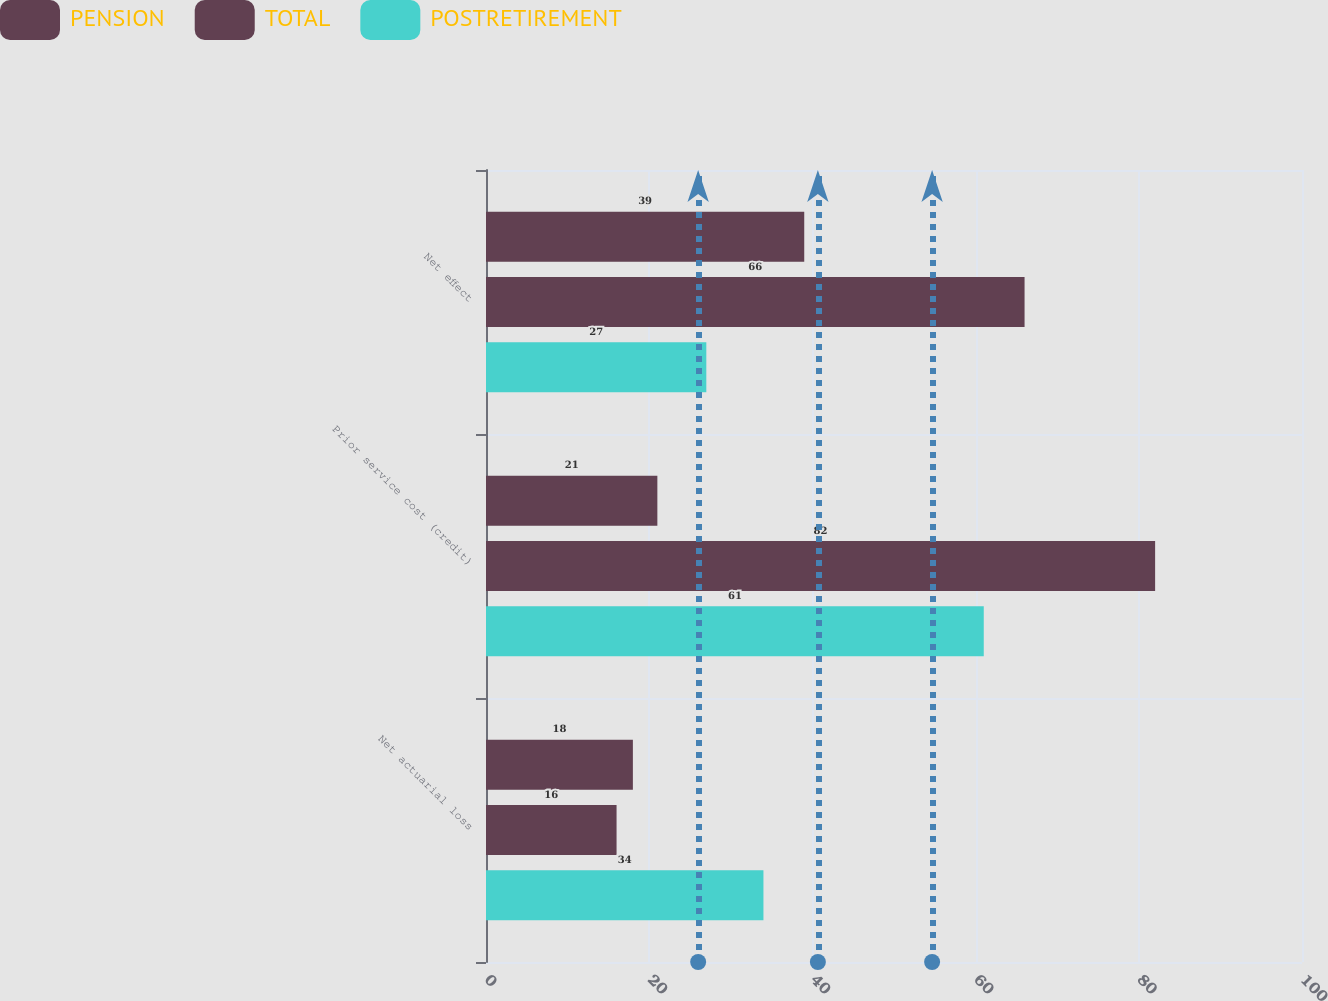<chart> <loc_0><loc_0><loc_500><loc_500><stacked_bar_chart><ecel><fcel>Net actuarial loss<fcel>Prior service cost (credit)<fcel>Net effect<nl><fcel>PENSION<fcel>18<fcel>21<fcel>39<nl><fcel>TOTAL<fcel>16<fcel>82<fcel>66<nl><fcel>POSTRETIREMENT<fcel>34<fcel>61<fcel>27<nl></chart> 